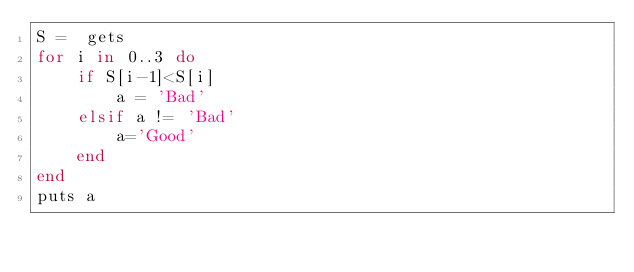Convert code to text. <code><loc_0><loc_0><loc_500><loc_500><_Ruby_>S =  gets
for i in 0..3 do
    if S[i-1]<S[i]
        a = 'Bad'
    elsif a != 'Bad'
        a='Good'
    end
end
puts a</code> 